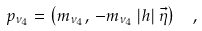<formula> <loc_0><loc_0><loc_500><loc_500>p _ { \nu _ { 4 } } = \left ( { m _ { \nu _ { 4 } } , \, - m _ { \nu _ { 4 } } \left | h \right | \vec { \eta } } \right ) \ \ ,</formula> 